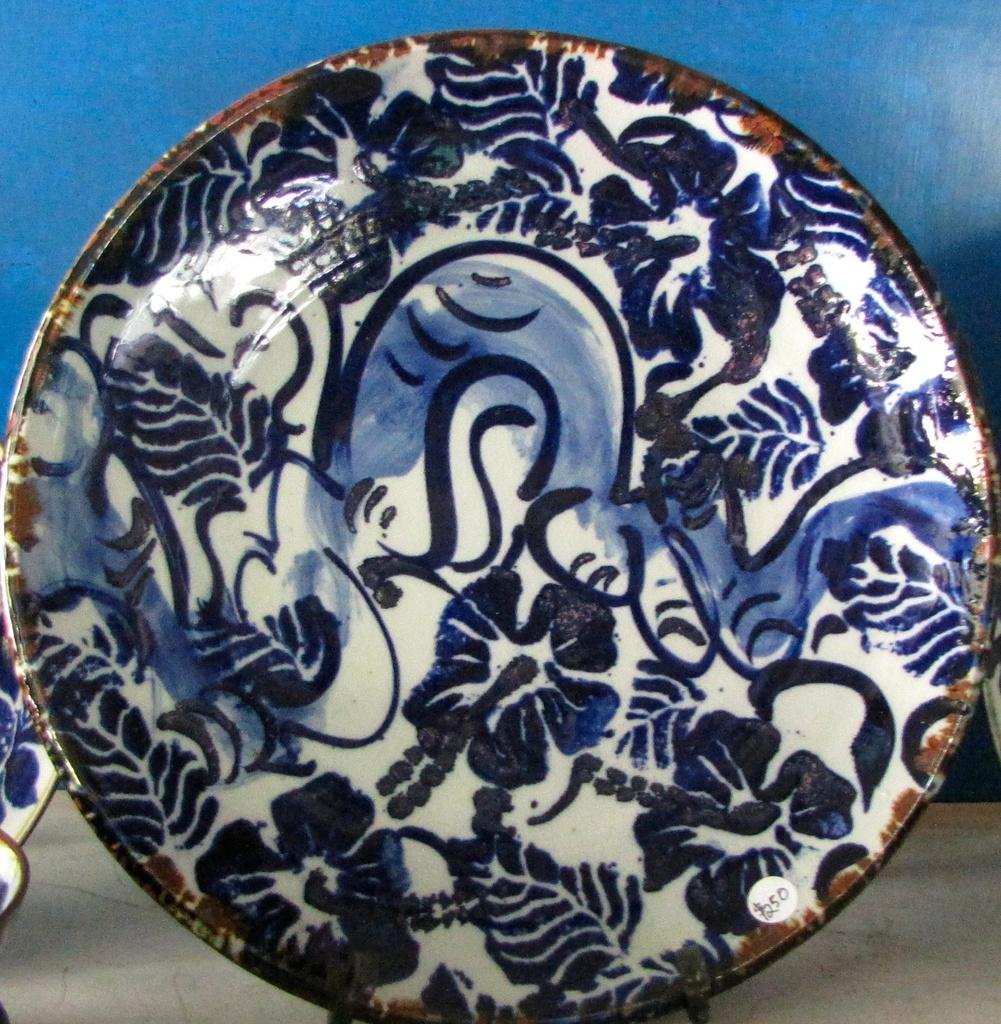What objects are on the floor in the image? There are plates on the floor in the image. What can be seen in the background of the image? There is a wall visible in the background of the image. Is there a corn field visible in the image? There is no corn field present in the image; only plates on the floor and a wall in the background are visible. 